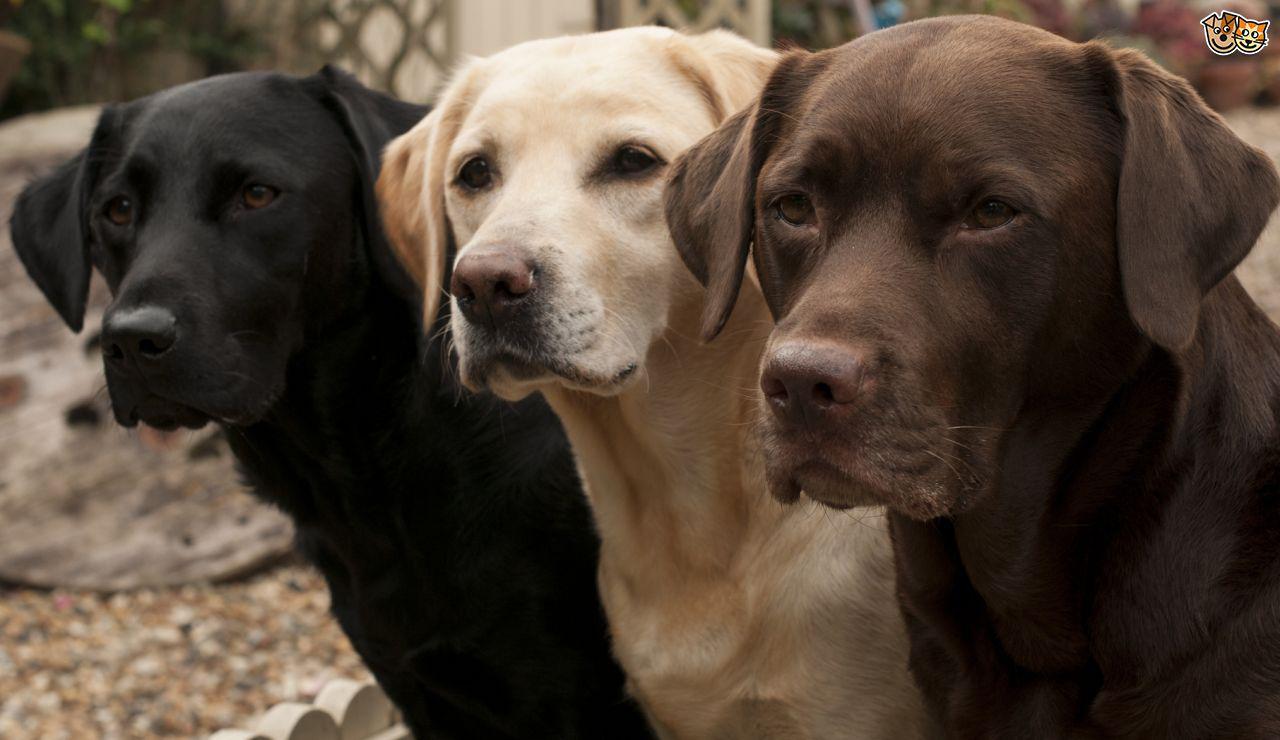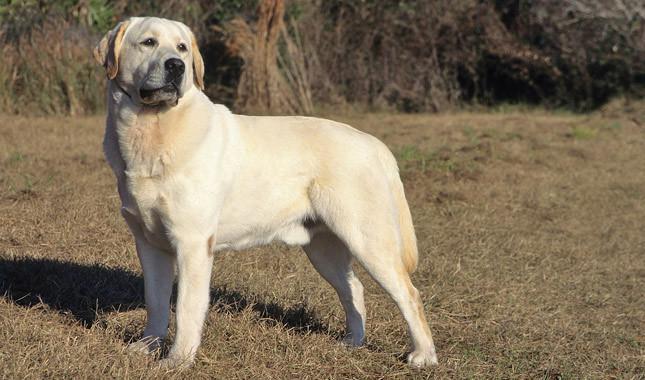The first image is the image on the left, the second image is the image on the right. For the images displayed, is the sentence "There are exactly two dogs in the left image." factually correct? Answer yes or no. No. 